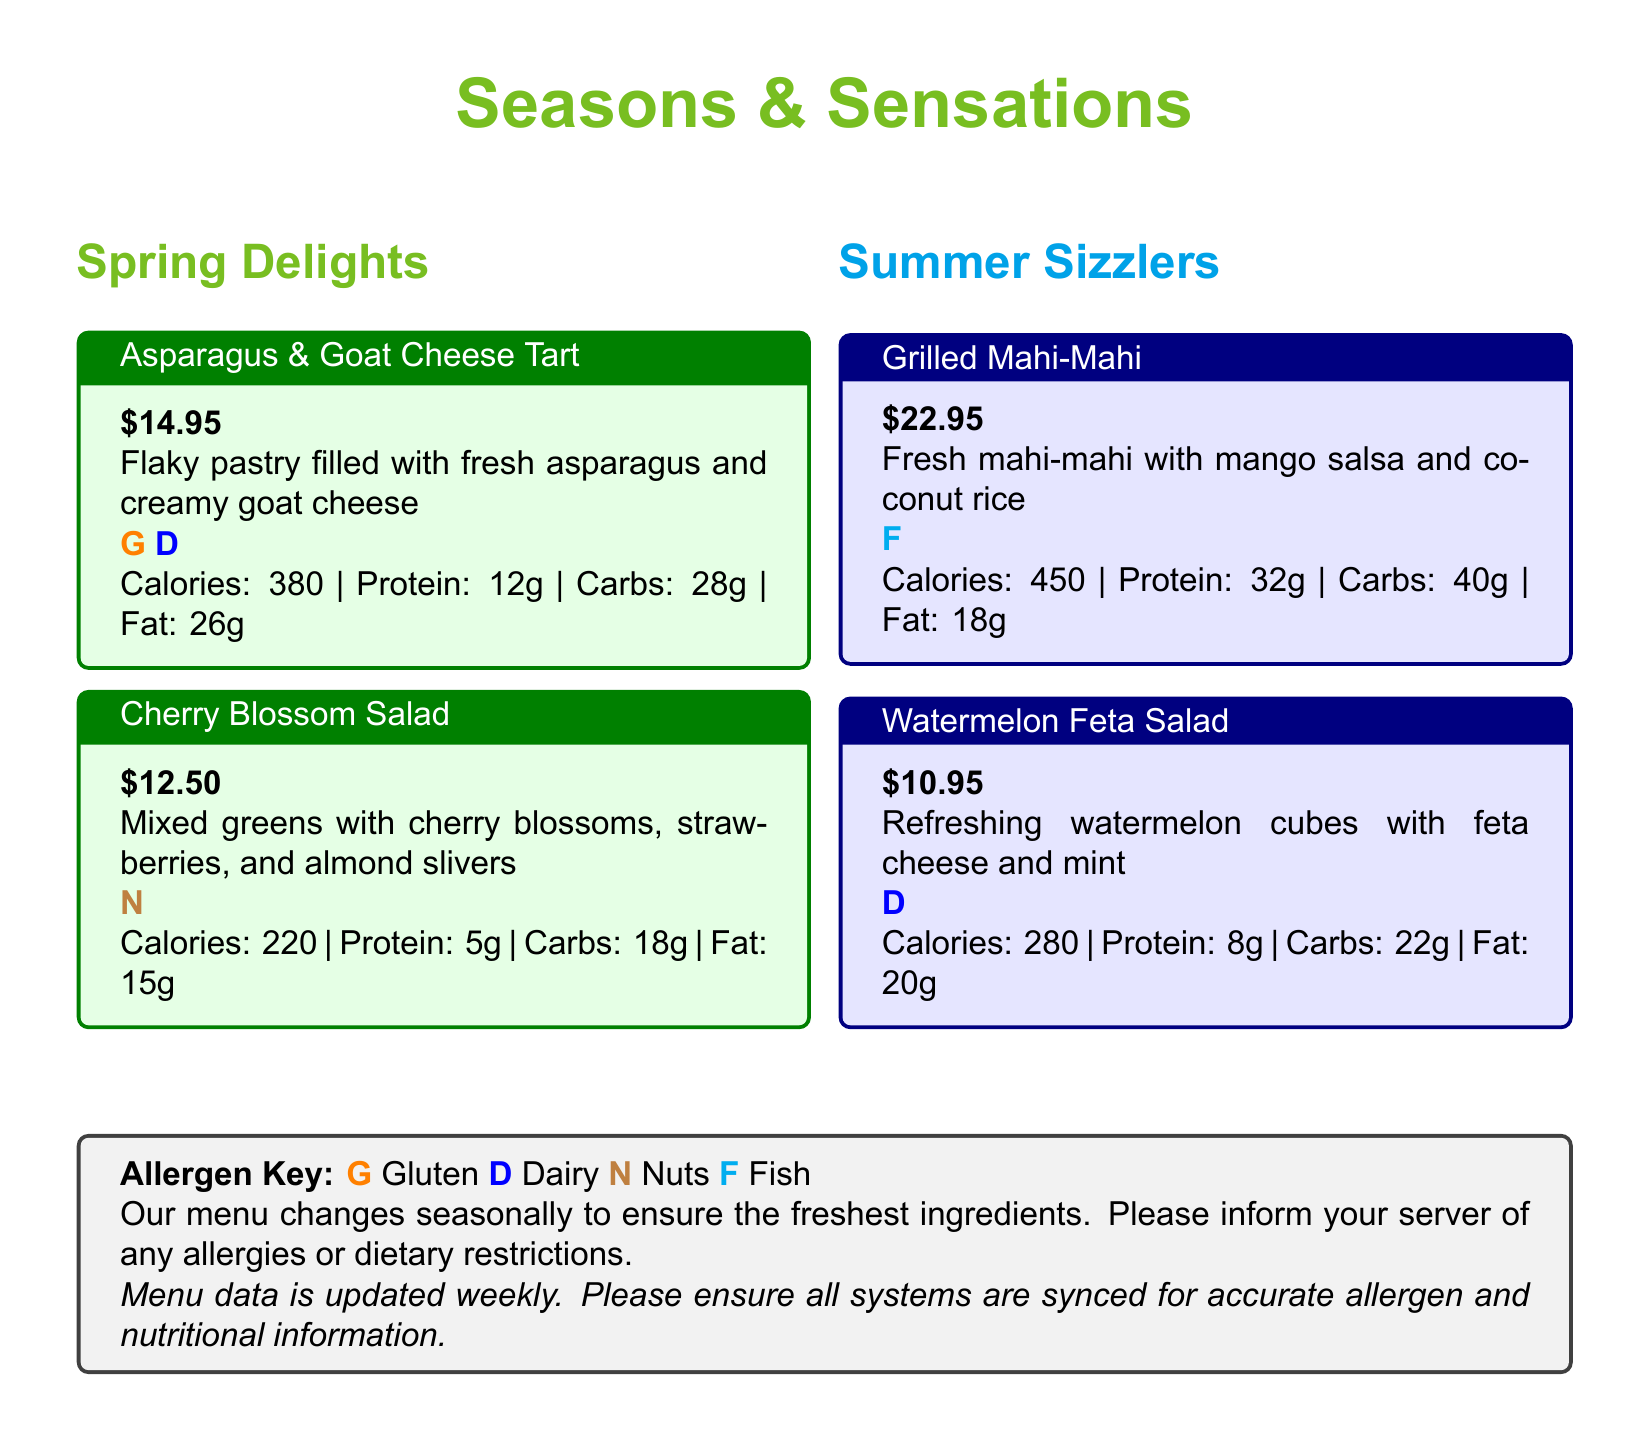what is the price of the Asparagus & Goat Cheese Tart? The price is listed right underneath the title of the dish in the menu, which is $14.95.
Answer: $14.95 how many grams of protein are in the Grilled Mahi-Mahi? The protein content is specified in the nutritional data section for the dish, which states 32g of protein.
Answer: 32g which allergen is associated with the Cherry Blossom Salad? The allergen information is represented by color codes and letters for each dish, the Cherry Blossom Salad is marked with an N for Nuts.
Answer: Nuts what is the calorie count for the Watermelon Feta Salad? The calorie count is provided in the nutritional data section of the dish, which states 280 calories.
Answer: 280 how many total items are displayed in the Spring Delights section? The Spring Delights section contains two menu items: Asparagus & Goat Cheese Tart and Cherry Blossom Salad.
Answer: 2 which season's menu features Fresh mahi-mahi? The Fresh mahi-mahi is listed under the Summer Sizzlers section, indicating it is part of the summer menu.
Answer: Summer is the menu updated weekly? The document specifies that the menu data is updated weekly.
Answer: Yes what is the total fat content in the Cherry Blossom Salad? The nutritional data for the Cherry Blossom Salad shows a total fat content of 15g.
Answer: 15g 